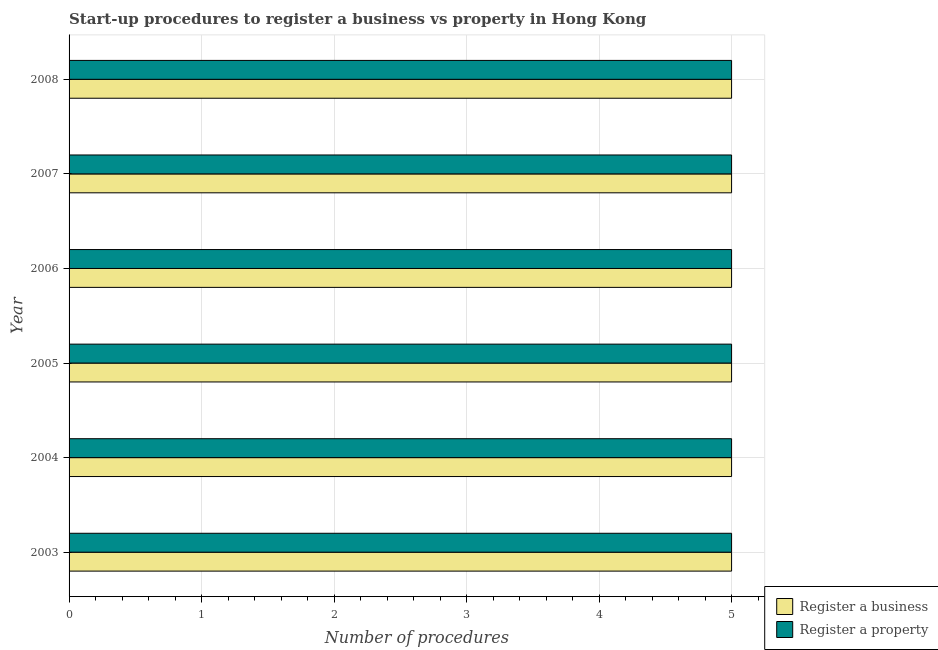How many groups of bars are there?
Offer a terse response. 6. Are the number of bars per tick equal to the number of legend labels?
Your answer should be very brief. Yes. How many bars are there on the 1st tick from the top?
Your response must be concise. 2. What is the number of procedures to register a property in 2008?
Give a very brief answer. 5. Across all years, what is the maximum number of procedures to register a property?
Your answer should be very brief. 5. Across all years, what is the minimum number of procedures to register a property?
Your answer should be compact. 5. In which year was the number of procedures to register a business maximum?
Provide a succinct answer. 2003. In which year was the number of procedures to register a business minimum?
Offer a very short reply. 2003. What is the total number of procedures to register a business in the graph?
Keep it short and to the point. 30. What is the difference between the number of procedures to register a business in 2006 and that in 2008?
Make the answer very short. 0. What is the average number of procedures to register a property per year?
Your response must be concise. 5. In the year 2007, what is the difference between the number of procedures to register a business and number of procedures to register a property?
Your answer should be compact. 0. Is the number of procedures to register a property in 2006 less than that in 2008?
Provide a short and direct response. No. What is the difference between the highest and the second highest number of procedures to register a business?
Your response must be concise. 0. Is the sum of the number of procedures to register a property in 2004 and 2005 greater than the maximum number of procedures to register a business across all years?
Offer a very short reply. Yes. What does the 2nd bar from the top in 2003 represents?
Give a very brief answer. Register a business. What does the 1st bar from the bottom in 2006 represents?
Offer a terse response. Register a business. Are all the bars in the graph horizontal?
Your response must be concise. Yes. Does the graph contain any zero values?
Keep it short and to the point. No. Does the graph contain grids?
Offer a very short reply. Yes. Where does the legend appear in the graph?
Keep it short and to the point. Bottom right. How many legend labels are there?
Make the answer very short. 2. How are the legend labels stacked?
Make the answer very short. Vertical. What is the title of the graph?
Offer a very short reply. Start-up procedures to register a business vs property in Hong Kong. Does "Goods and services" appear as one of the legend labels in the graph?
Your answer should be very brief. No. What is the label or title of the X-axis?
Make the answer very short. Number of procedures. What is the Number of procedures of Register a business in 2003?
Your answer should be compact. 5. What is the Number of procedures of Register a property in 2003?
Offer a very short reply. 5. What is the Number of procedures of Register a business in 2004?
Provide a short and direct response. 5. What is the Number of procedures of Register a property in 2004?
Make the answer very short. 5. What is the Number of procedures in Register a business in 2006?
Your answer should be compact. 5. What is the Number of procedures in Register a property in 2006?
Offer a terse response. 5. What is the Number of procedures of Register a business in 2007?
Keep it short and to the point. 5. What is the Number of procedures in Register a business in 2008?
Ensure brevity in your answer.  5. What is the total Number of procedures of Register a business in the graph?
Your answer should be compact. 30. What is the difference between the Number of procedures in Register a business in 2003 and that in 2004?
Make the answer very short. 0. What is the difference between the Number of procedures in Register a property in 2003 and that in 2004?
Offer a very short reply. 0. What is the difference between the Number of procedures in Register a business in 2003 and that in 2006?
Your answer should be compact. 0. What is the difference between the Number of procedures of Register a property in 2003 and that in 2007?
Your answer should be very brief. 0. What is the difference between the Number of procedures of Register a property in 2003 and that in 2008?
Offer a terse response. 0. What is the difference between the Number of procedures of Register a business in 2004 and that in 2006?
Make the answer very short. 0. What is the difference between the Number of procedures in Register a business in 2004 and that in 2007?
Provide a succinct answer. 0. What is the difference between the Number of procedures of Register a property in 2004 and that in 2007?
Give a very brief answer. 0. What is the difference between the Number of procedures of Register a business in 2005 and that in 2006?
Ensure brevity in your answer.  0. What is the difference between the Number of procedures in Register a business in 2005 and that in 2007?
Ensure brevity in your answer.  0. What is the difference between the Number of procedures in Register a business in 2005 and that in 2008?
Give a very brief answer. 0. What is the difference between the Number of procedures of Register a business in 2006 and that in 2007?
Make the answer very short. 0. What is the difference between the Number of procedures in Register a property in 2006 and that in 2008?
Offer a very short reply. 0. What is the difference between the Number of procedures in Register a business in 2007 and that in 2008?
Keep it short and to the point. 0. What is the difference between the Number of procedures of Register a property in 2007 and that in 2008?
Give a very brief answer. 0. What is the difference between the Number of procedures in Register a business in 2003 and the Number of procedures in Register a property in 2004?
Provide a succinct answer. 0. What is the difference between the Number of procedures of Register a business in 2003 and the Number of procedures of Register a property in 2006?
Ensure brevity in your answer.  0. What is the difference between the Number of procedures in Register a business in 2003 and the Number of procedures in Register a property in 2007?
Ensure brevity in your answer.  0. What is the difference between the Number of procedures in Register a business in 2003 and the Number of procedures in Register a property in 2008?
Make the answer very short. 0. What is the difference between the Number of procedures in Register a business in 2004 and the Number of procedures in Register a property in 2005?
Provide a succinct answer. 0. What is the difference between the Number of procedures of Register a business in 2004 and the Number of procedures of Register a property in 2006?
Give a very brief answer. 0. What is the difference between the Number of procedures of Register a business in 2005 and the Number of procedures of Register a property in 2007?
Provide a succinct answer. 0. What is the difference between the Number of procedures of Register a business in 2006 and the Number of procedures of Register a property in 2007?
Your answer should be compact. 0. What is the difference between the Number of procedures of Register a business in 2006 and the Number of procedures of Register a property in 2008?
Ensure brevity in your answer.  0. What is the average Number of procedures in Register a business per year?
Keep it short and to the point. 5. What is the average Number of procedures in Register a property per year?
Give a very brief answer. 5. In the year 2003, what is the difference between the Number of procedures of Register a business and Number of procedures of Register a property?
Give a very brief answer. 0. In the year 2005, what is the difference between the Number of procedures of Register a business and Number of procedures of Register a property?
Provide a short and direct response. 0. In the year 2007, what is the difference between the Number of procedures of Register a business and Number of procedures of Register a property?
Your response must be concise. 0. What is the ratio of the Number of procedures in Register a business in 2003 to that in 2004?
Give a very brief answer. 1. What is the ratio of the Number of procedures in Register a business in 2003 to that in 2005?
Keep it short and to the point. 1. What is the ratio of the Number of procedures of Register a property in 2003 to that in 2005?
Your response must be concise. 1. What is the ratio of the Number of procedures in Register a business in 2003 to that in 2006?
Provide a short and direct response. 1. What is the ratio of the Number of procedures in Register a business in 2003 to that in 2007?
Your answer should be very brief. 1. What is the ratio of the Number of procedures of Register a property in 2003 to that in 2007?
Ensure brevity in your answer.  1. What is the ratio of the Number of procedures of Register a business in 2003 to that in 2008?
Your response must be concise. 1. What is the ratio of the Number of procedures in Register a property in 2003 to that in 2008?
Provide a short and direct response. 1. What is the ratio of the Number of procedures of Register a business in 2004 to that in 2005?
Offer a very short reply. 1. What is the ratio of the Number of procedures of Register a business in 2004 to that in 2006?
Offer a very short reply. 1. What is the ratio of the Number of procedures in Register a property in 2004 to that in 2006?
Keep it short and to the point. 1. What is the ratio of the Number of procedures in Register a business in 2004 to that in 2008?
Your answer should be compact. 1. What is the ratio of the Number of procedures of Register a property in 2004 to that in 2008?
Give a very brief answer. 1. What is the ratio of the Number of procedures of Register a property in 2005 to that in 2006?
Give a very brief answer. 1. What is the ratio of the Number of procedures of Register a business in 2005 to that in 2007?
Ensure brevity in your answer.  1. What is the ratio of the Number of procedures in Register a business in 2005 to that in 2008?
Provide a succinct answer. 1. What is the ratio of the Number of procedures in Register a business in 2006 to that in 2007?
Offer a very short reply. 1. What is the ratio of the Number of procedures of Register a business in 2006 to that in 2008?
Ensure brevity in your answer.  1. What is the ratio of the Number of procedures of Register a business in 2007 to that in 2008?
Offer a very short reply. 1. What is the difference between the highest and the second highest Number of procedures in Register a business?
Provide a short and direct response. 0. What is the difference between the highest and the second highest Number of procedures of Register a property?
Make the answer very short. 0. What is the difference between the highest and the lowest Number of procedures of Register a property?
Provide a succinct answer. 0. 